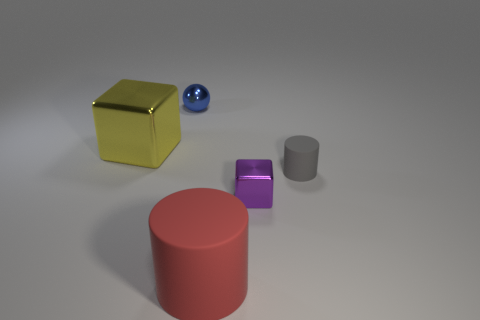Does this image remind you of any particular style or artistic movement? The simplicity of the objects and the clean background in the image evoke characteristics of minimalism, an artistic movement that emphasizes the essentials of shape and form while eliminating all non-essential forms, features, or concepts. 